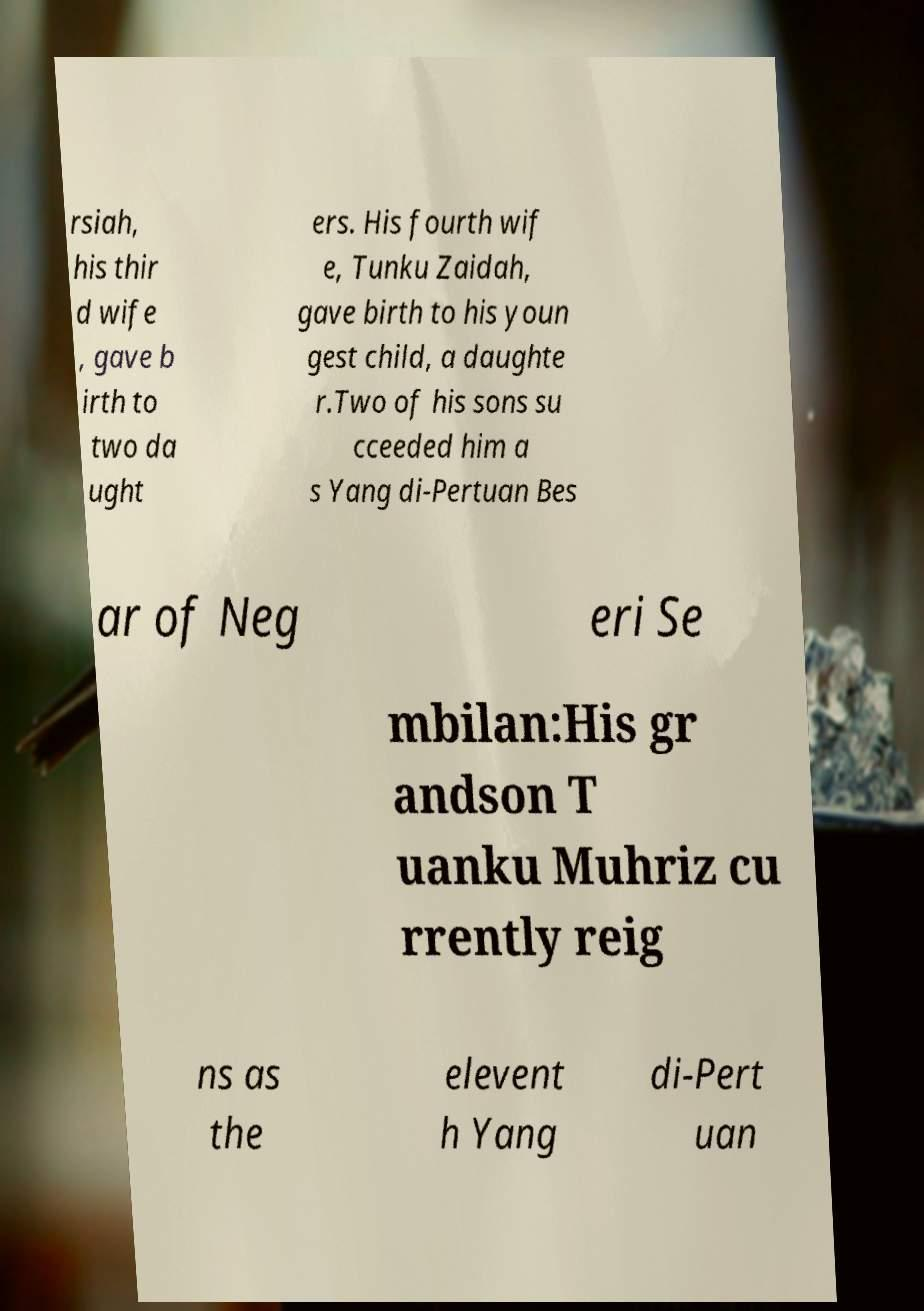There's text embedded in this image that I need extracted. Can you transcribe it verbatim? rsiah, his thir d wife , gave b irth to two da ught ers. His fourth wif e, Tunku Zaidah, gave birth to his youn gest child, a daughte r.Two of his sons su cceeded him a s Yang di-Pertuan Bes ar of Neg eri Se mbilan:His gr andson T uanku Muhriz cu rrently reig ns as the elevent h Yang di-Pert uan 